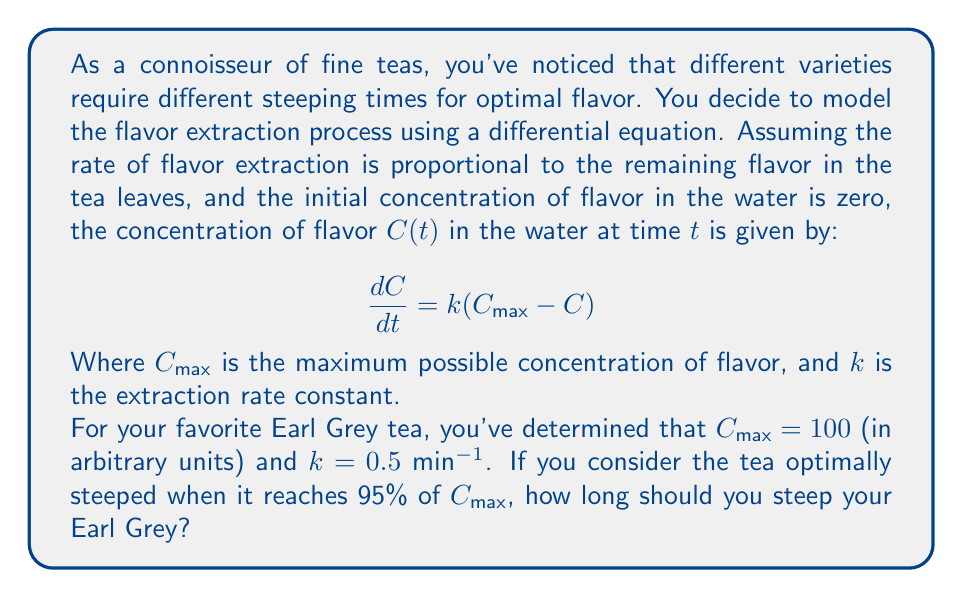Provide a solution to this math problem. Let's approach this step-by-step:

1) First, we need to solve the differential equation. The general solution for this type of equation is:

   $$C(t) = C_{\text{max}}(1 - e^{-kt})$$

2) We're given that $C_{\text{max}} = 100$ and $k = 0.5$ min^(-1). Substituting these values:

   $$C(t) = 100(1 - e^{-0.5t})$$

3) We want to find the time $t$ when $C(t)$ reaches 95% of $C_{\text{max}}$. In other words:

   $$C(t) = 0.95 \times C_{\text{max}} = 0.95 \times 100 = 95$$

4) Now we can set up an equation:

   $$95 = 100(1 - e^{-0.5t})$$

5) Solving for $t$:

   $$0.95 = 1 - e^{-0.5t}$$
   $$e^{-0.5t} = 0.05$$
   $$-0.5t = \ln(0.05)$$
   $$t = -\frac{\ln(0.05)}{0.5} \approx 5.99 \text{ minutes}$$

6) Rounding to the nearest second, we get 5 minutes and 59 seconds.
Answer: The optimal steeping time for Earl Grey tea under these conditions is approximately 5 minutes and 59 seconds. 